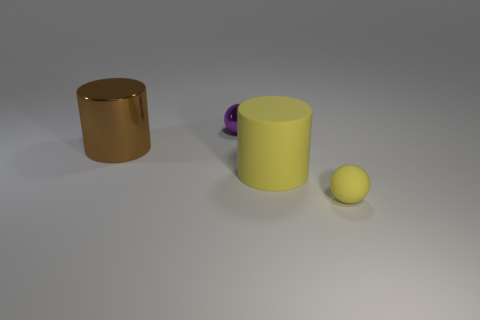What shape is the matte thing that is the same size as the brown metal object?
Your response must be concise. Cylinder. What shape is the big rubber object that is the same color as the matte sphere?
Provide a short and direct response. Cylinder. Does the tiny ball that is right of the tiny purple metallic object have the same material as the large thing in front of the brown thing?
Your answer should be compact. Yes. There is a thing that is made of the same material as the tiny yellow sphere; what is its size?
Provide a short and direct response. Large. The small thing in front of the purple shiny object has what shape?
Your answer should be compact. Sphere. There is a big cylinder behind the large yellow object; does it have the same color as the sphere in front of the yellow matte cylinder?
Provide a succinct answer. No. There is a rubber object that is the same color as the large matte cylinder; what size is it?
Keep it short and to the point. Small. Is there a big yellow matte cylinder?
Your response must be concise. Yes. There is a tiny yellow object that is in front of the yellow thing that is left of the tiny thing in front of the brown thing; what shape is it?
Provide a short and direct response. Sphere. There is a large brown metal cylinder; how many large cylinders are right of it?
Ensure brevity in your answer.  1. 